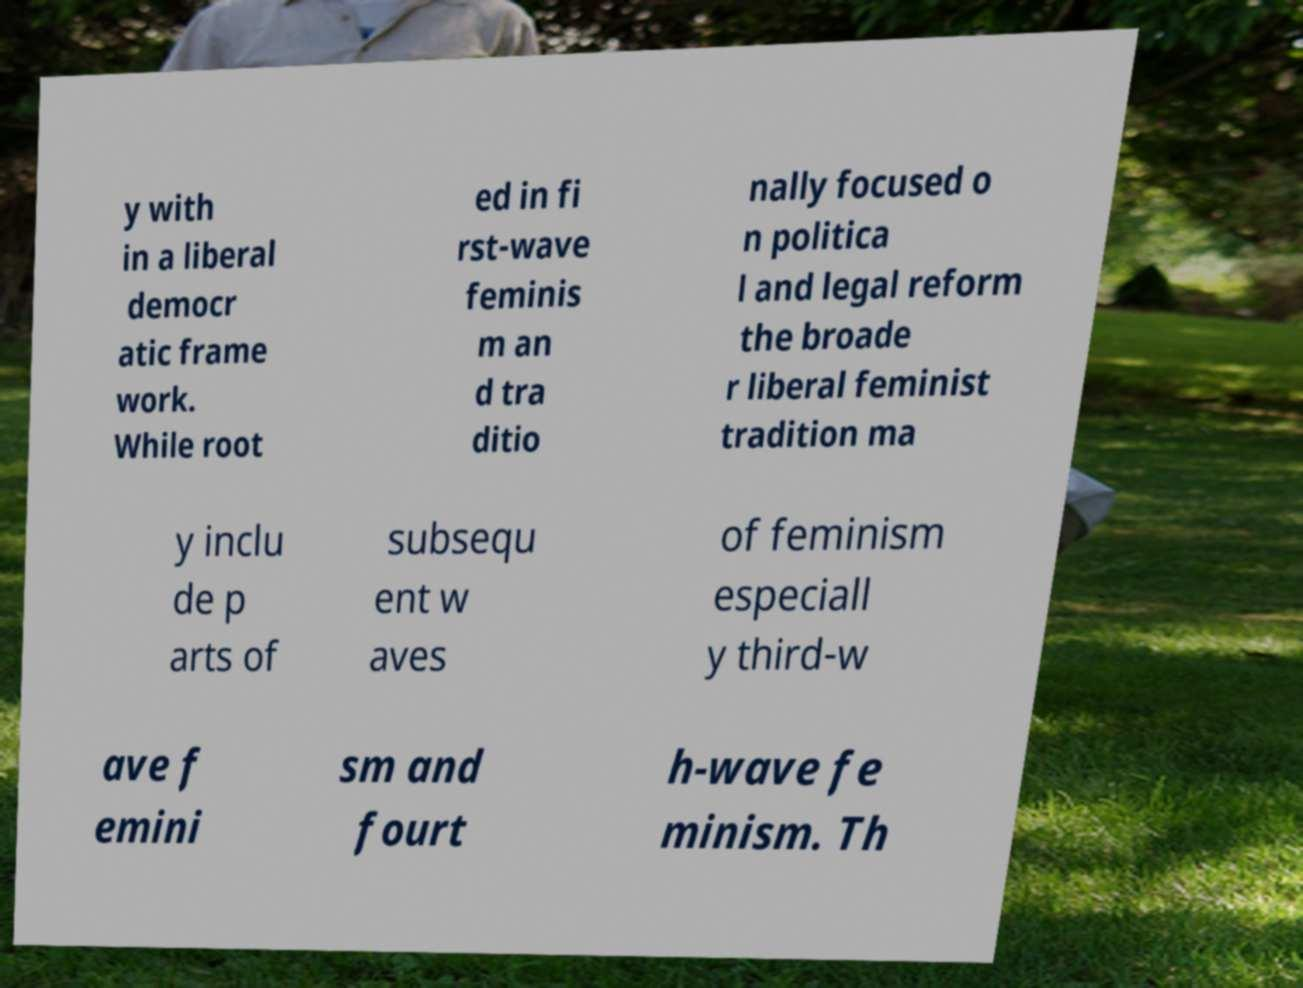For documentation purposes, I need the text within this image transcribed. Could you provide that? y with in a liberal democr atic frame work. While root ed in fi rst-wave feminis m an d tra ditio nally focused o n politica l and legal reform the broade r liberal feminist tradition ma y inclu de p arts of subsequ ent w aves of feminism especiall y third-w ave f emini sm and fourt h-wave fe minism. Th 